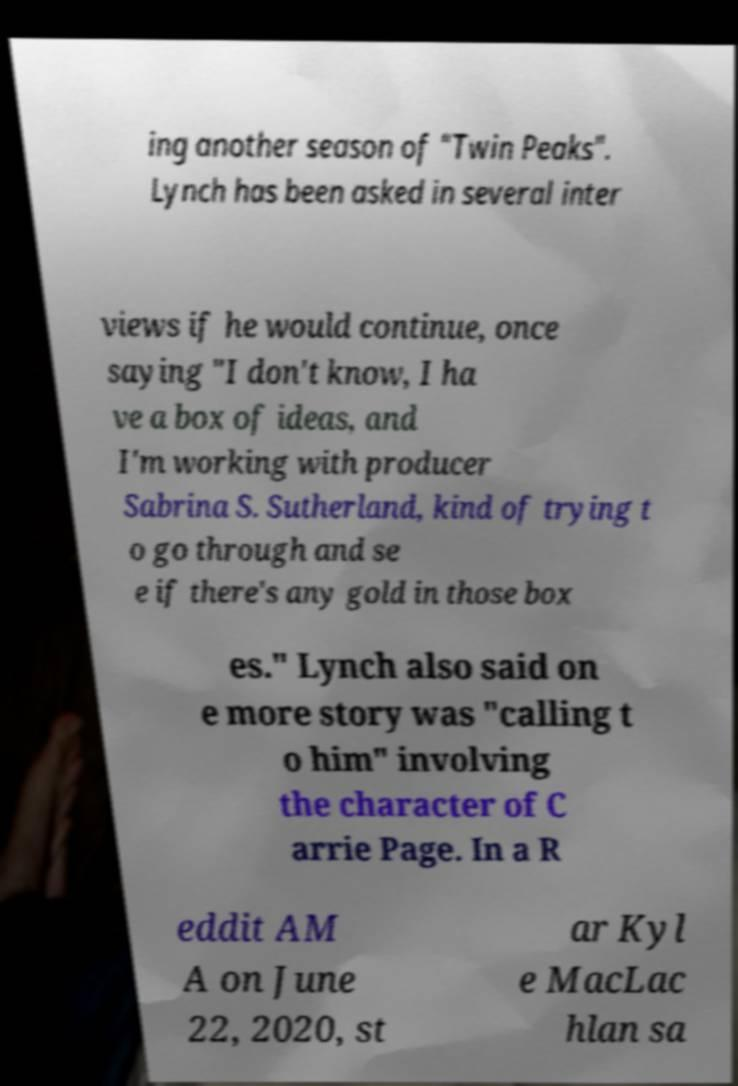What messages or text are displayed in this image? I need them in a readable, typed format. ing another season of "Twin Peaks". Lynch has been asked in several inter views if he would continue, once saying "I don't know, I ha ve a box of ideas, and I'm working with producer Sabrina S. Sutherland, kind of trying t o go through and se e if there's any gold in those box es." Lynch also said on e more story was "calling t o him" involving the character of C arrie Page. In a R eddit AM A on June 22, 2020, st ar Kyl e MacLac hlan sa 